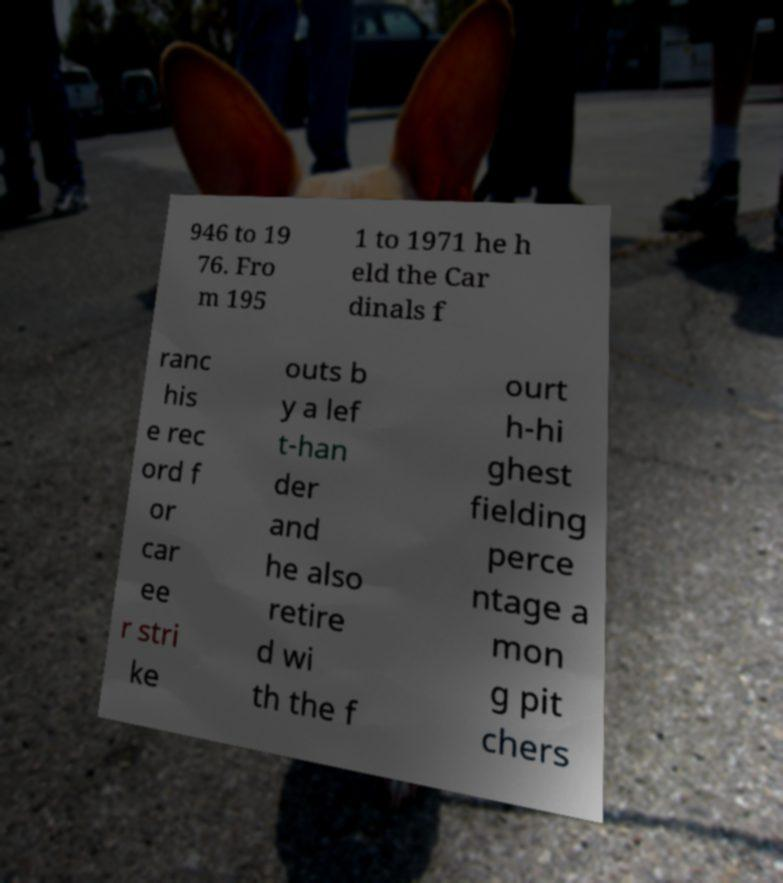For documentation purposes, I need the text within this image transcribed. Could you provide that? 946 to 19 76. Fro m 195 1 to 1971 he h eld the Car dinals f ranc his e rec ord f or car ee r stri ke outs b y a lef t-han der and he also retire d wi th the f ourt h-hi ghest fielding perce ntage a mon g pit chers 